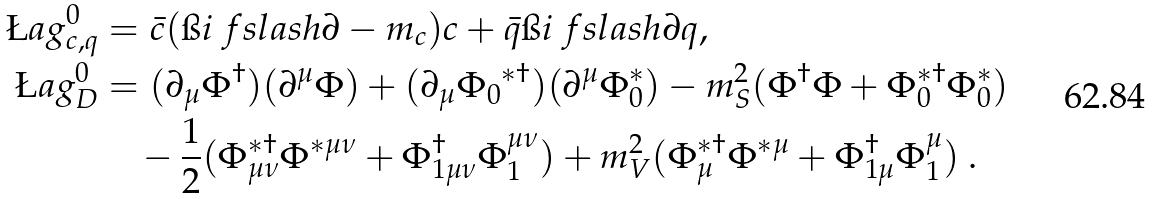<formula> <loc_0><loc_0><loc_500><loc_500>\L a g _ { c , q } ^ { 0 } & = \bar { c } ( \i i \ f s l a s h { \partial } - m _ { c } ) c + \bar { q } \i i \ f s l a s h { \partial } q , \\ \L a g _ { D } ^ { 0 } & = ( \partial _ { \mu } \Phi ^ { \dagger } ) ( \partial ^ { \mu } \Phi ) + ( \partial _ { \mu } { \Phi _ { 0 } } ^ { * \dagger } ) ( \partial ^ { \mu } \Phi _ { 0 } ^ { * } ) - m _ { S } ^ { 2 } ( \Phi ^ { \dagger } \Phi + \Phi _ { 0 } ^ { * \dagger } \Phi _ { 0 } ^ { * } ) \\ & \quad - \frac { 1 } { 2 } ( \Phi _ { \mu \nu } ^ { * \dagger } \Phi ^ { * \mu \nu } + \Phi _ { 1 \mu \nu } ^ { \dagger } \Phi _ { 1 } ^ { \mu \nu } ) + m _ { V } ^ { 2 } ( \Phi _ { \mu } ^ { * \dagger } \Phi ^ { * \mu } + \Phi _ { 1 \mu } ^ { \dagger } \Phi _ { 1 } ^ { \mu } ) \ .</formula> 